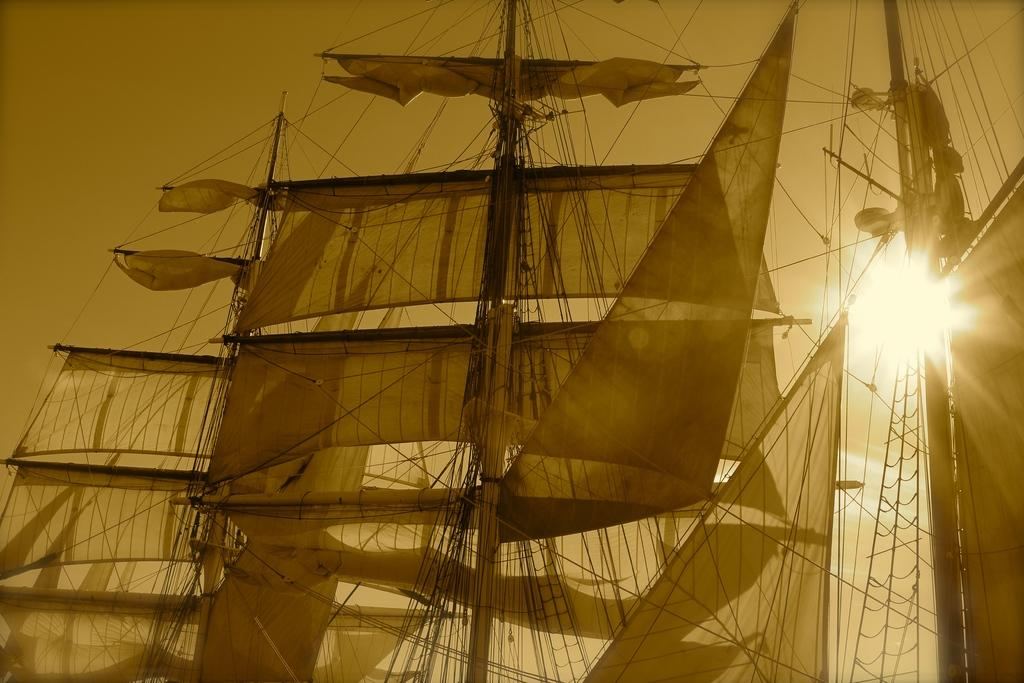What can be seen in the image that is used for transportation on water? There are boats in the image that are used for transportation on water. What feature is present on the boats? There are poles on the boats. What is hanging on the poles? Clothes are hanging on the poles. What type of adhesive material is visible in the image? There are tapes in the image. What is visible in the sky in the image? The sky is visible at the top of the image, and the sun is observable in the sky. What type of baseball equipment can be seen in the image? There is no baseball equipment present in the image. What holiday is being celebrated in the image? There is no indication of a holiday being celebrated in the image. 